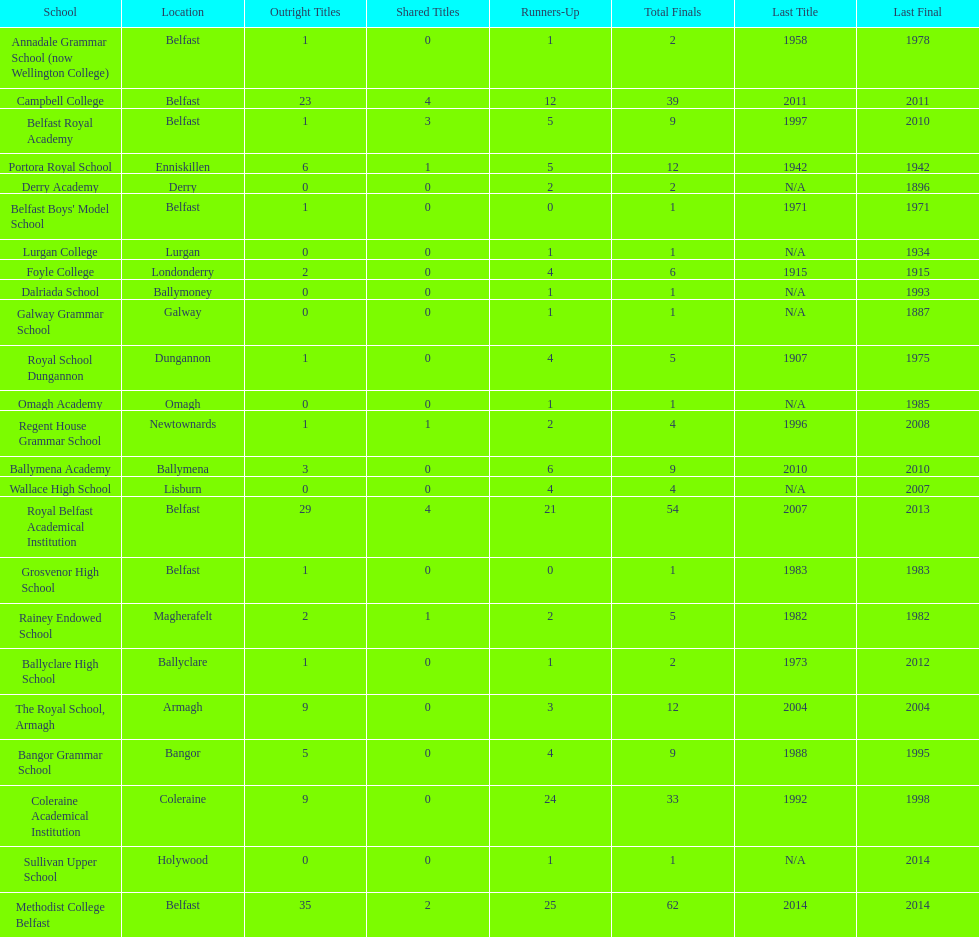What is the difference in runners-up from coleraine academical institution and royal school dungannon? 20. 